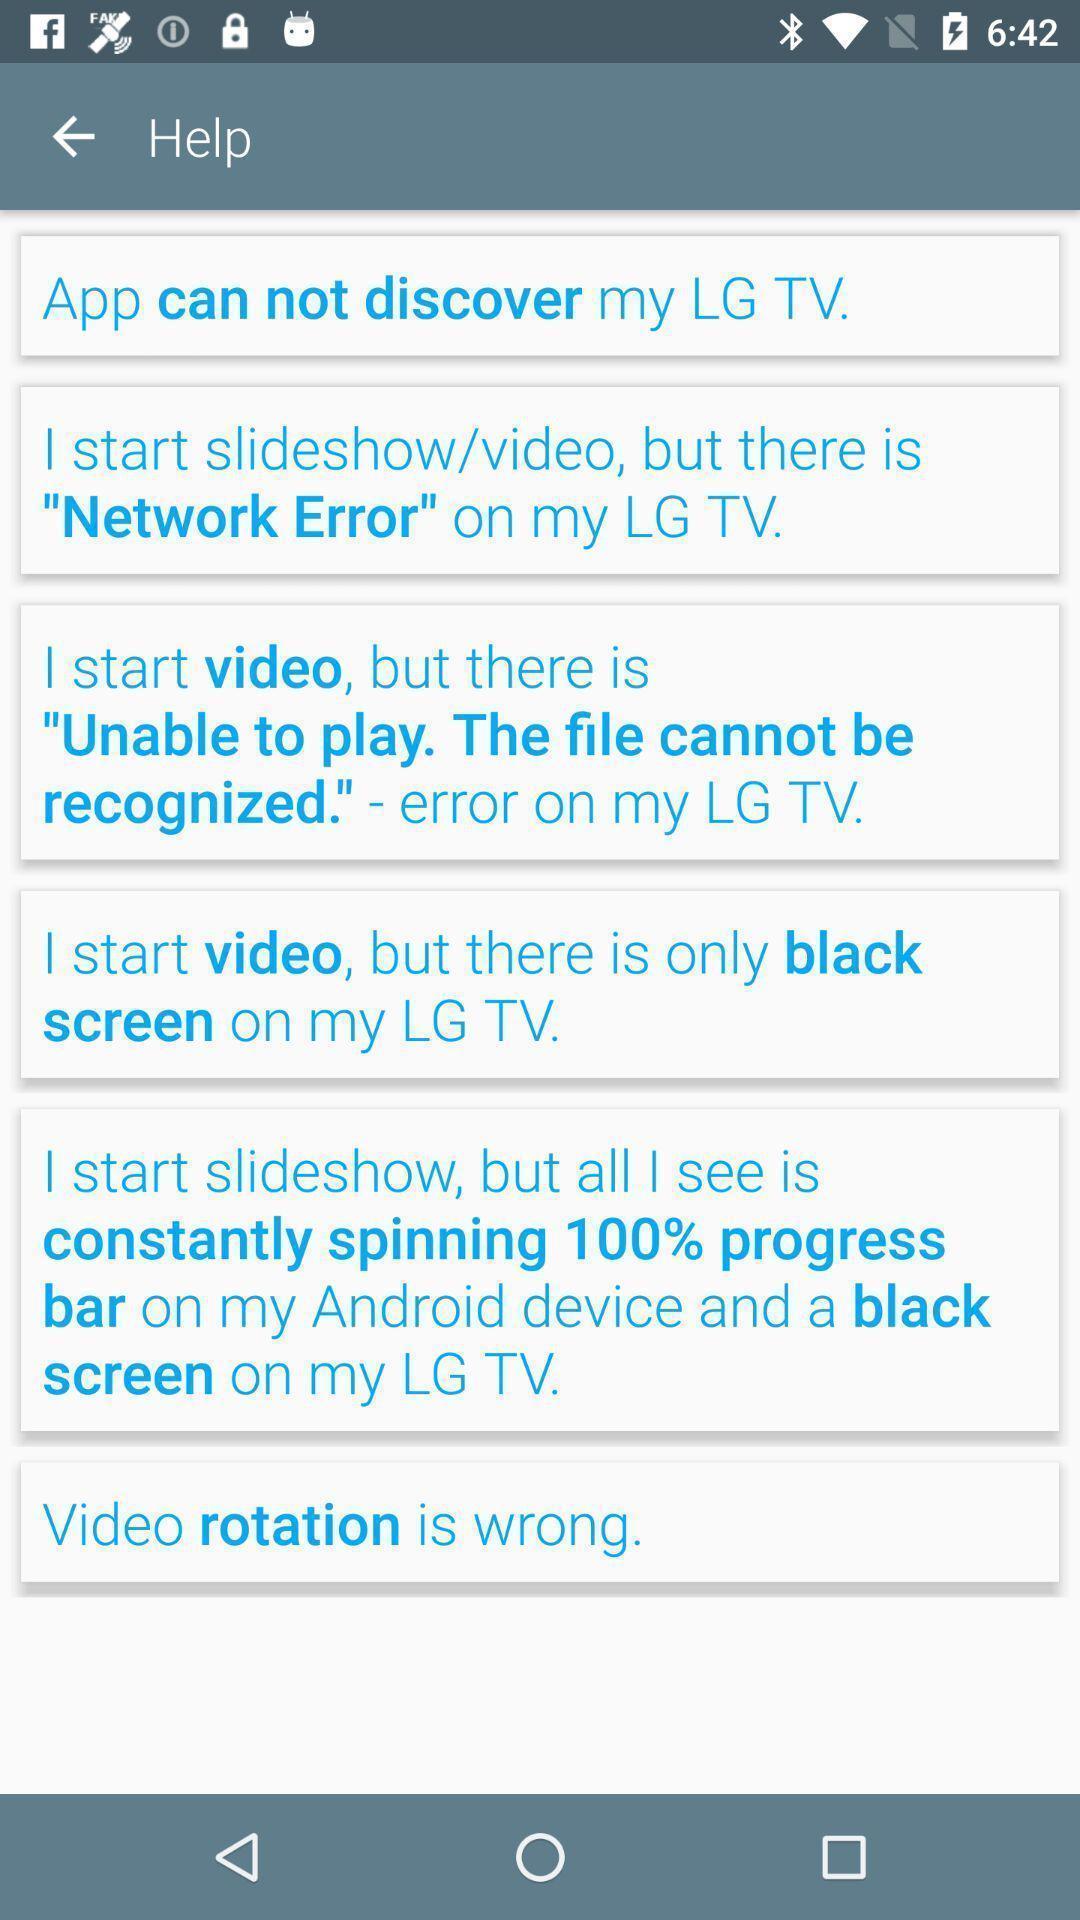Summarize the information in this screenshot. Page showing help screen of tv app. 